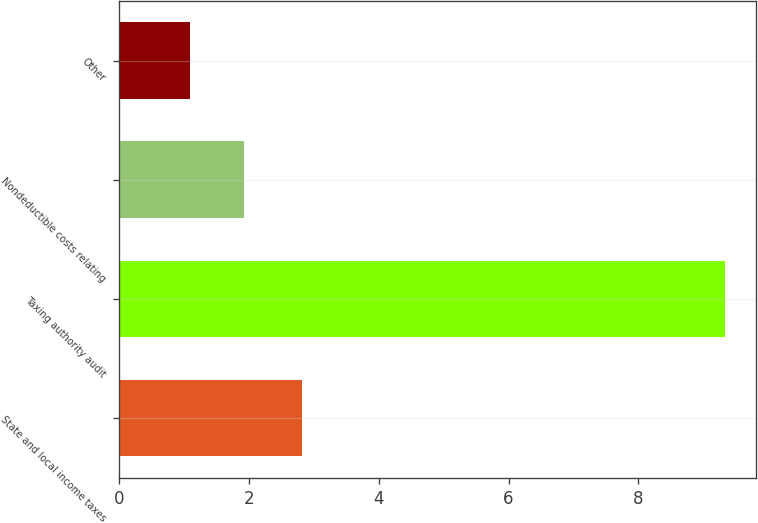Convert chart. <chart><loc_0><loc_0><loc_500><loc_500><bar_chart><fcel>State and local income taxes<fcel>Taxing authority audit<fcel>Nondeductible costs relating<fcel>Other<nl><fcel>2.81<fcel>9.34<fcel>1.92<fcel>1.09<nl></chart> 